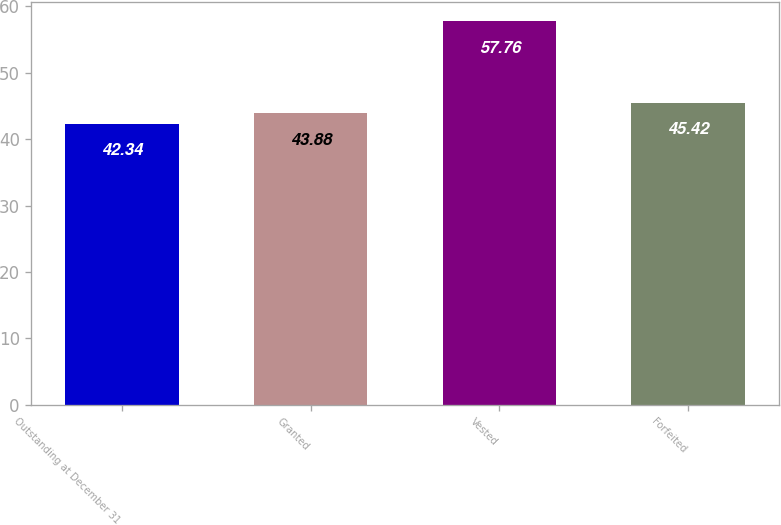Convert chart to OTSL. <chart><loc_0><loc_0><loc_500><loc_500><bar_chart><fcel>Outstanding at December 31<fcel>Granted<fcel>Vested<fcel>Forfeited<nl><fcel>42.34<fcel>43.88<fcel>57.76<fcel>45.42<nl></chart> 